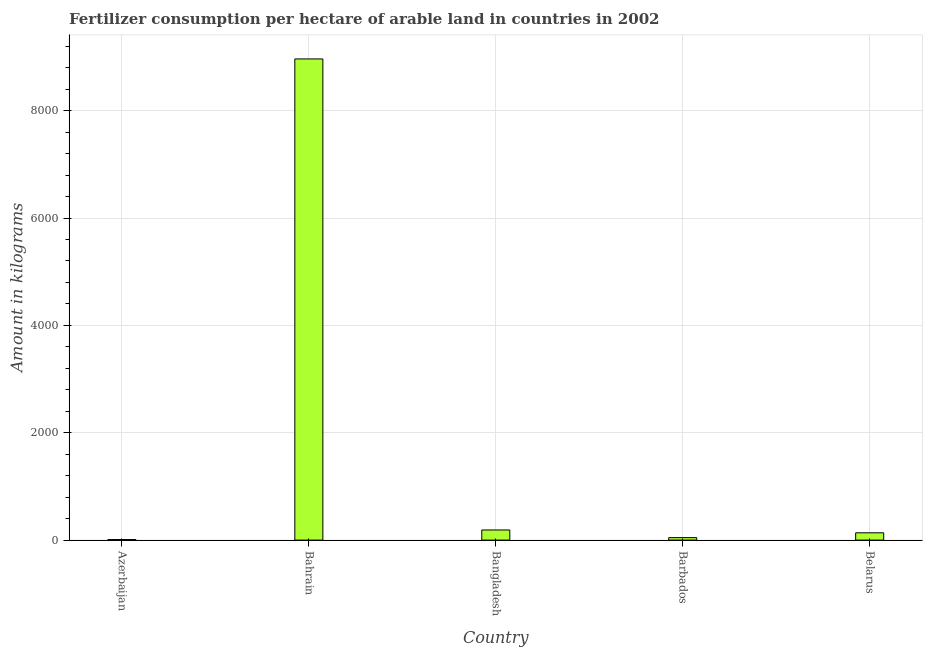Does the graph contain any zero values?
Your answer should be compact. No. What is the title of the graph?
Give a very brief answer. Fertilizer consumption per hectare of arable land in countries in 2002 . What is the label or title of the Y-axis?
Provide a succinct answer. Amount in kilograms. What is the amount of fertilizer consumption in Bahrain?
Your response must be concise. 8964.5. Across all countries, what is the maximum amount of fertilizer consumption?
Provide a succinct answer. 8964.5. Across all countries, what is the minimum amount of fertilizer consumption?
Ensure brevity in your answer.  10.43. In which country was the amount of fertilizer consumption maximum?
Ensure brevity in your answer.  Bahrain. In which country was the amount of fertilizer consumption minimum?
Your answer should be very brief. Azerbaijan. What is the sum of the amount of fertilizer consumption?
Your answer should be compact. 9345.42. What is the difference between the amount of fertilizer consumption in Bahrain and Bangladesh?
Provide a short and direct response. 8775.86. What is the average amount of fertilizer consumption per country?
Offer a very short reply. 1869.08. What is the median amount of fertilizer consumption?
Your answer should be very brief. 135.99. In how many countries, is the amount of fertilizer consumption greater than 400 kg?
Offer a very short reply. 1. What is the ratio of the amount of fertilizer consumption in Bahrain to that in Bangladesh?
Give a very brief answer. 47.52. Is the amount of fertilizer consumption in Azerbaijan less than that in Belarus?
Make the answer very short. Yes. Is the difference between the amount of fertilizer consumption in Bahrain and Barbados greater than the difference between any two countries?
Your response must be concise. No. What is the difference between the highest and the second highest amount of fertilizer consumption?
Provide a short and direct response. 8775.86. Is the sum of the amount of fertilizer consumption in Bangladesh and Belarus greater than the maximum amount of fertilizer consumption across all countries?
Your answer should be compact. No. What is the difference between the highest and the lowest amount of fertilizer consumption?
Offer a very short reply. 8954.07. How many countries are there in the graph?
Offer a very short reply. 5. Are the values on the major ticks of Y-axis written in scientific E-notation?
Offer a very short reply. No. What is the Amount in kilograms of Azerbaijan?
Provide a succinct answer. 10.43. What is the Amount in kilograms in Bahrain?
Provide a succinct answer. 8964.5. What is the Amount in kilograms of Bangladesh?
Ensure brevity in your answer.  188.64. What is the Amount in kilograms in Barbados?
Your response must be concise. 45.86. What is the Amount in kilograms in Belarus?
Your answer should be very brief. 135.99. What is the difference between the Amount in kilograms in Azerbaijan and Bahrain?
Ensure brevity in your answer.  -8954.07. What is the difference between the Amount in kilograms in Azerbaijan and Bangladesh?
Offer a very short reply. -178.21. What is the difference between the Amount in kilograms in Azerbaijan and Barbados?
Provide a succinct answer. -35.42. What is the difference between the Amount in kilograms in Azerbaijan and Belarus?
Provide a short and direct response. -125.55. What is the difference between the Amount in kilograms in Bahrain and Bangladesh?
Provide a succinct answer. 8775.86. What is the difference between the Amount in kilograms in Bahrain and Barbados?
Give a very brief answer. 8918.64. What is the difference between the Amount in kilograms in Bahrain and Belarus?
Offer a terse response. 8828.51. What is the difference between the Amount in kilograms in Bangladesh and Barbados?
Your response must be concise. 142.78. What is the difference between the Amount in kilograms in Bangladesh and Belarus?
Ensure brevity in your answer.  52.65. What is the difference between the Amount in kilograms in Barbados and Belarus?
Offer a very short reply. -90.13. What is the ratio of the Amount in kilograms in Azerbaijan to that in Bangladesh?
Provide a succinct answer. 0.06. What is the ratio of the Amount in kilograms in Azerbaijan to that in Barbados?
Offer a very short reply. 0.23. What is the ratio of the Amount in kilograms in Azerbaijan to that in Belarus?
Keep it short and to the point. 0.08. What is the ratio of the Amount in kilograms in Bahrain to that in Bangladesh?
Make the answer very short. 47.52. What is the ratio of the Amount in kilograms in Bahrain to that in Barbados?
Your response must be concise. 195.49. What is the ratio of the Amount in kilograms in Bahrain to that in Belarus?
Your answer should be very brief. 65.92. What is the ratio of the Amount in kilograms in Bangladesh to that in Barbados?
Provide a short and direct response. 4.11. What is the ratio of the Amount in kilograms in Bangladesh to that in Belarus?
Offer a very short reply. 1.39. What is the ratio of the Amount in kilograms in Barbados to that in Belarus?
Ensure brevity in your answer.  0.34. 